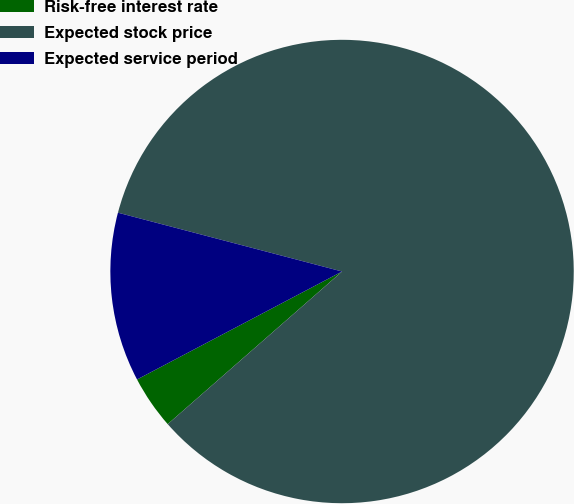<chart> <loc_0><loc_0><loc_500><loc_500><pie_chart><fcel>Risk-free interest rate<fcel>Expected stock price<fcel>Expected service period<nl><fcel>3.73%<fcel>84.47%<fcel>11.8%<nl></chart> 